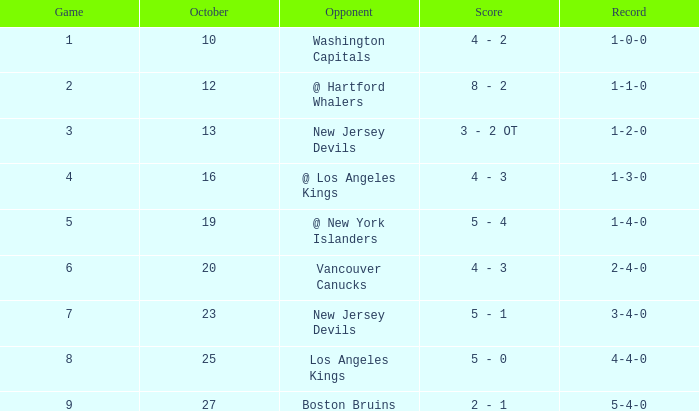In october, which game boasts the highest score, 9? 27.0. 